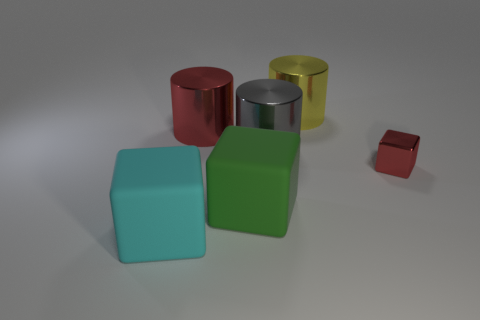There is a red metal thing that is the same shape as the cyan rubber thing; what size is it?
Provide a succinct answer. Small. Is there any other thing that has the same size as the red metallic cube?
Provide a succinct answer. No. The large cylinder in front of the red metal thing that is to the left of the red object that is to the right of the big yellow cylinder is made of what material?
Give a very brief answer. Metal. What is the color of the metal thing that is the same shape as the cyan rubber thing?
Make the answer very short. Red. Do the yellow shiny cylinder and the cyan object have the same size?
Provide a short and direct response. Yes. Are the big cube to the left of the large green matte object and the cylinder that is in front of the large red metallic cylinder made of the same material?
Ensure brevity in your answer.  No. Is the number of red metallic cubes behind the big green thing greater than the number of red shiny blocks behind the yellow metal cylinder?
Your answer should be compact. Yes. How many rubber things are cyan cylinders or big cyan blocks?
Keep it short and to the point. 1. What material is the object that is the same color as the metal cube?
Your answer should be compact. Metal. Are there fewer cyan matte blocks that are on the right side of the big gray cylinder than big metal objects that are on the right side of the red metal cylinder?
Provide a short and direct response. Yes. 